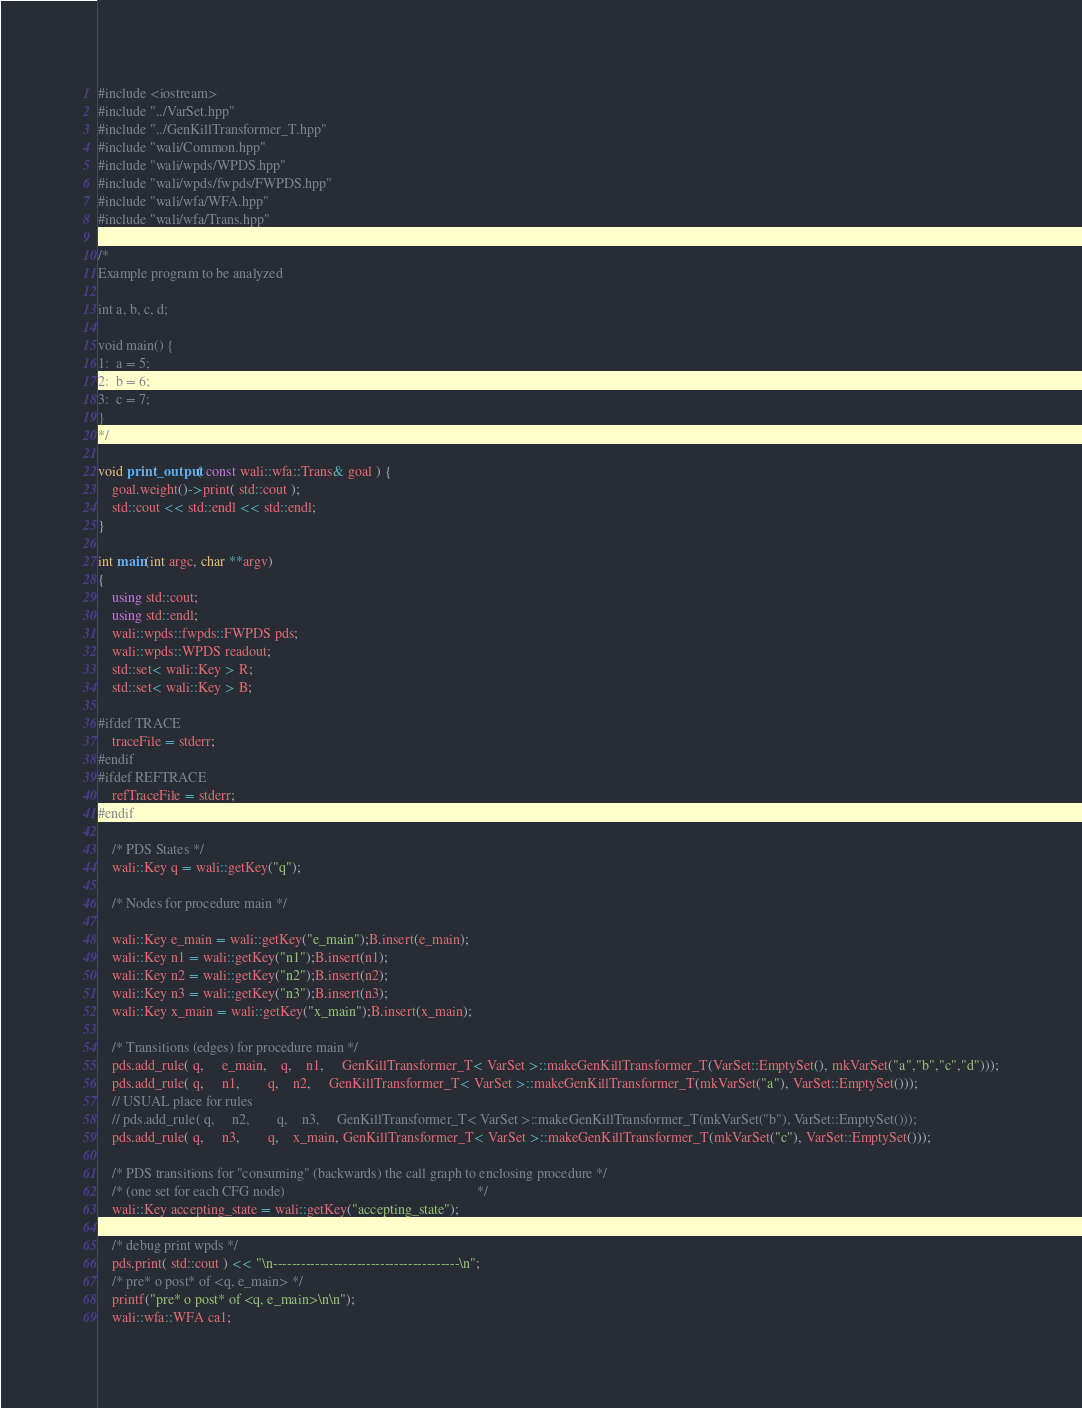<code> <loc_0><loc_0><loc_500><loc_500><_C++_>#include <iostream>
#include "../VarSet.hpp"
#include "../GenKillTransformer_T.hpp"
#include "wali/Common.hpp"
#include "wali/wpds/WPDS.hpp"
#include "wali/wpds/fwpds/FWPDS.hpp"
#include "wali/wfa/WFA.hpp"
#include "wali/wfa/Trans.hpp"

/*
Example program to be analyzed

int a, b, c, d;

void main() {
1:  a = 5;
2:  b = 6;
3:  c = 7;
}
*/

void print_output( const wali::wfa::Trans& goal ) {
    goal.weight()->print( std::cout );
    std::cout << std::endl << std::endl;
}

int main(int argc, char **argv)
{
    using std::cout;
    using std::endl;
    wali::wpds::fwpds::FWPDS pds;
    wali::wpds::WPDS readout;
    std::set< wali::Key > R;
    std::set< wali::Key > B;

#ifdef TRACE
    traceFile = stderr;
#endif
#ifdef REFTRACE
    refTraceFile = stderr;
#endif

    /* PDS States */
    wali::Key q = wali::getKey("q");

    /* Nodes for procedure main */

    wali::Key e_main = wali::getKey("e_main");B.insert(e_main);
    wali::Key n1 = wali::getKey("n1");B.insert(n1);
    wali::Key n2 = wali::getKey("n2");B.insert(n2);
    wali::Key n3 = wali::getKey("n3");B.insert(n3);
    wali::Key x_main = wali::getKey("x_main");B.insert(x_main);

    /* Transitions (edges) for procedure main */
    pds.add_rule( q,     e_main,    q,    n1,     GenKillTransformer_T< VarSet >::makeGenKillTransformer_T(VarSet::EmptySet(), mkVarSet("a","b","c","d")));
    pds.add_rule( q,     n1,        q,    n2,     GenKillTransformer_T< VarSet >::makeGenKillTransformer_T(mkVarSet("a"), VarSet::EmptySet()));
    // USUAL place for rules
    // pds.add_rule( q,     n2,        q,    n3,     GenKillTransformer_T< VarSet >::makeGenKillTransformer_T(mkVarSet("b"), VarSet::EmptySet()));
    pds.add_rule( q,     n3,        q,    x_main, GenKillTransformer_T< VarSet >::makeGenKillTransformer_T(mkVarSet("c"), VarSet::EmptySet()));

    /* PDS transitions for "consuming" (backwards) the call graph to enclosing procedure */
    /* (one set for each CFG node)                                                       */
    wali::Key accepting_state = wali::getKey("accepting_state");

    /* debug print wpds */
    pds.print( std::cout ) << "\n----------------------------------------\n";
    /* pre* o post* of <q, e_main> */
    printf("pre* o post* of <q, e_main>\n\n");
    wali::wfa::WFA ca1;</code> 